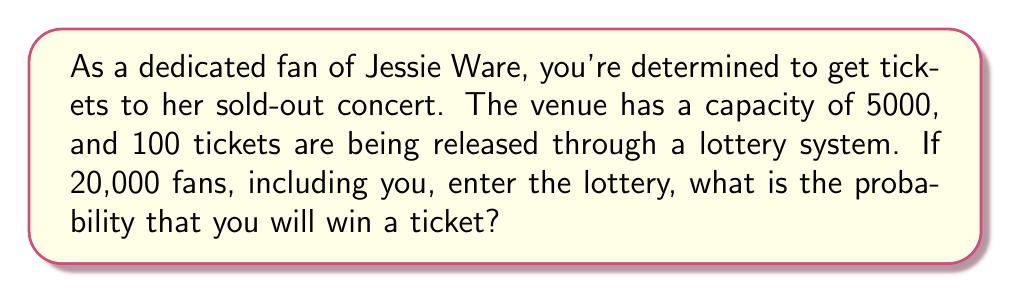Can you solve this math problem? To solve this problem, we need to calculate the probability of a single event (you winning a ticket) out of all possible outcomes. Let's break it down step-by-step:

1. Total number of tickets available: 100
2. Total number of fans entering the lottery: 20,000
3. We need to calculate the probability of you being one of the 100 winners out of 20,000 participants.

The probability of an event is calculated as:

$$ P(\text{event}) = \frac{\text{number of favorable outcomes}}{\text{total number of possible outcomes}} $$

In this case:
- Favorable outcomes: 100 (the number of tickets available)
- Total possible outcomes: 20,000 (the total number of fans entering the lottery)

Therefore, the probability is:

$$ P(\text{winning a ticket}) = \frac{100}{20,000} = \frac{1}{200} = 0.005 $$

To express this as a percentage:

$$ 0.005 \times 100\% = 0.5\% $$
Answer: The probability of winning a ticket to the sold-out Jessie Ware concert is $\frac{1}{200}$ or $0.005$ or $0.5\%$. 